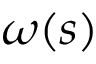<formula> <loc_0><loc_0><loc_500><loc_500>\omega ( s )</formula> 